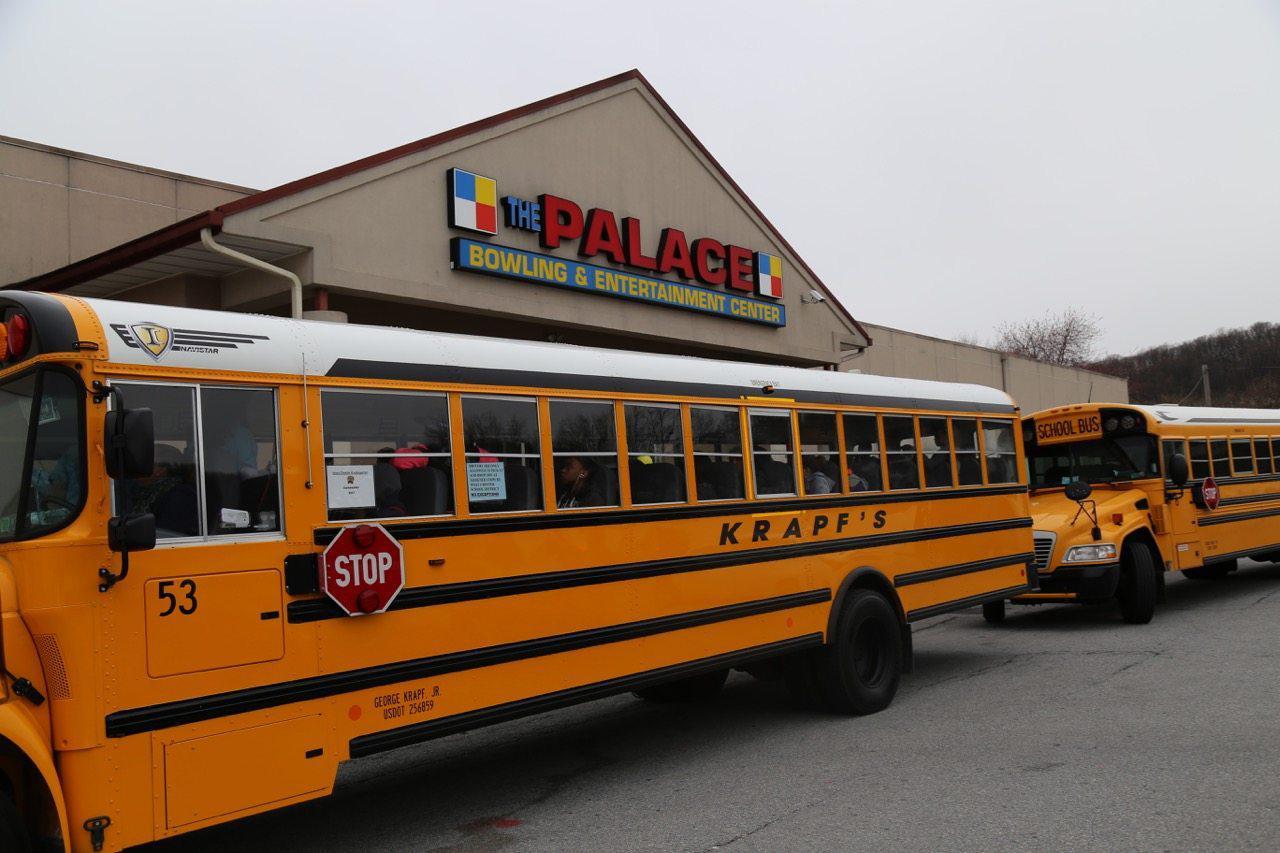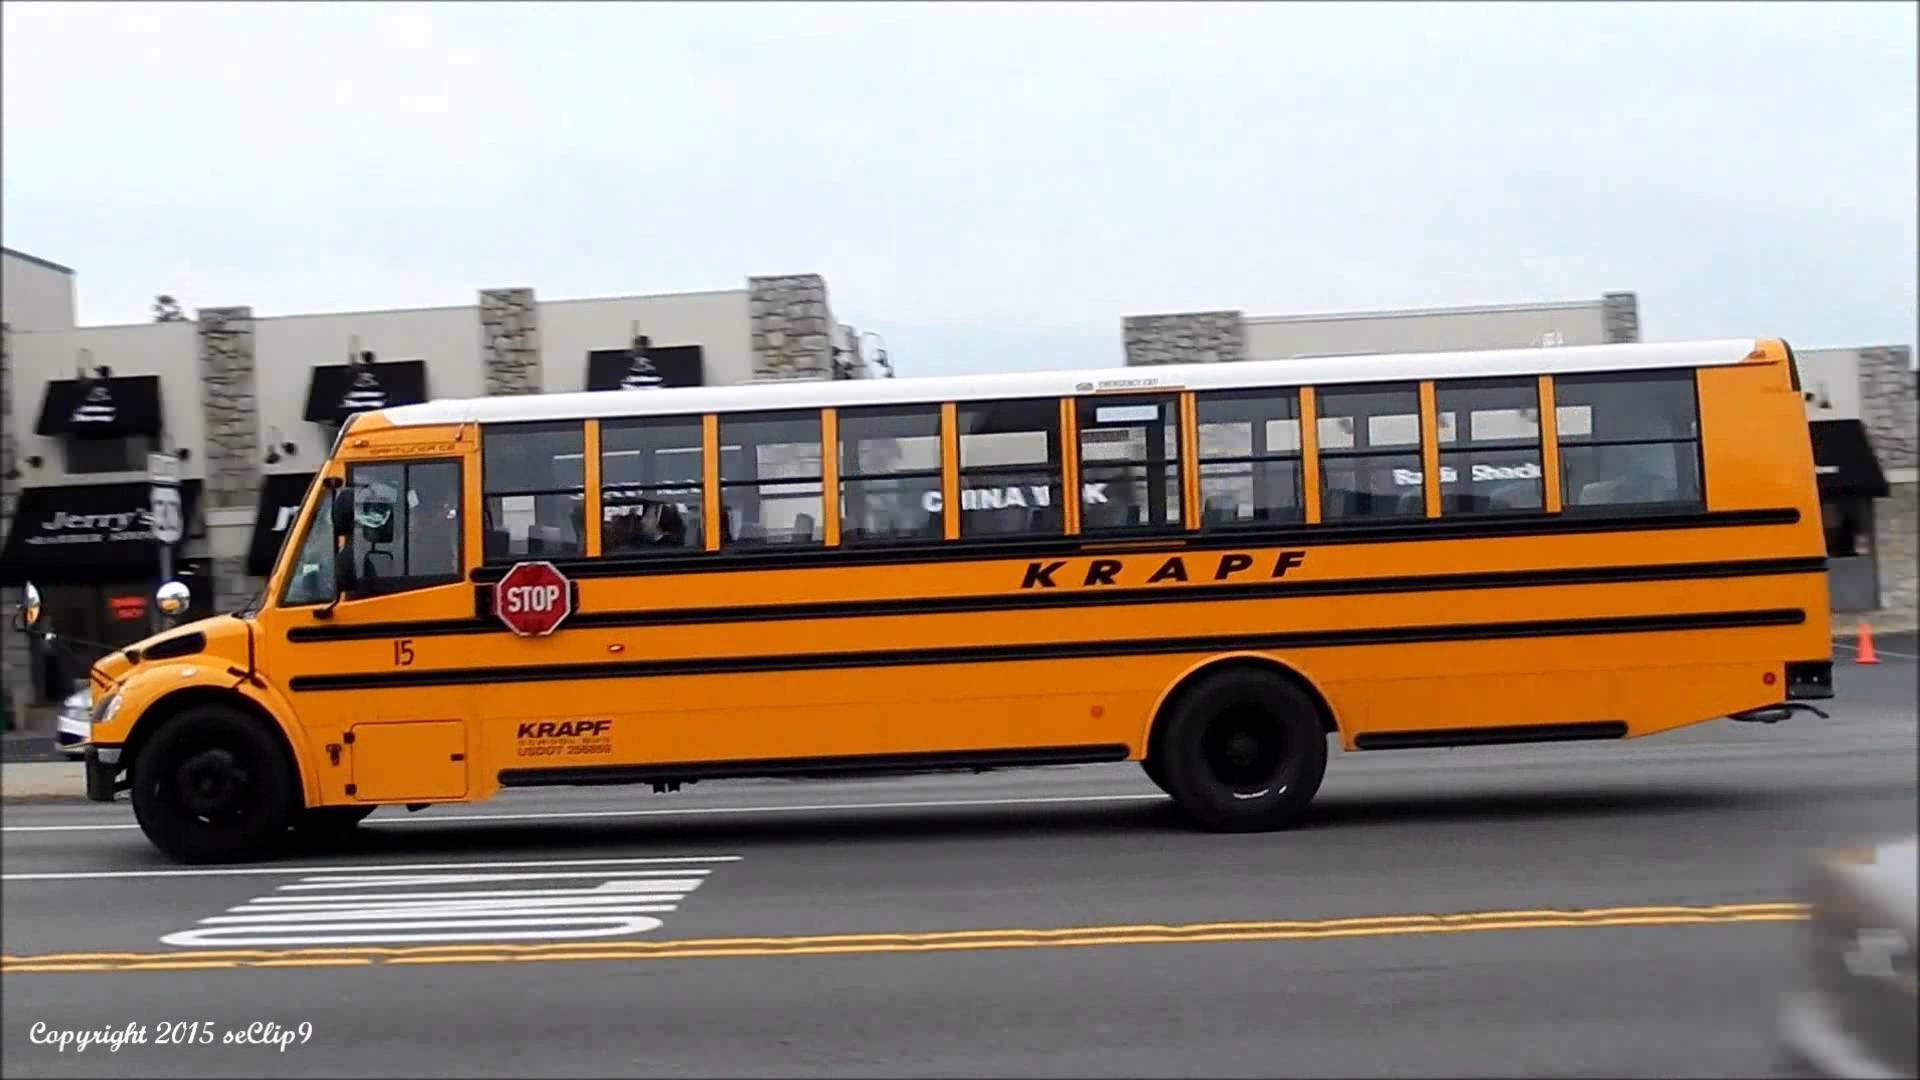The first image is the image on the left, the second image is the image on the right. For the images shown, is this caption "A school bus seen from above has a white roof with identifying number, and a handicap access door directly behind a passenger door with steps." true? Answer yes or no. No. The first image is the image on the left, the second image is the image on the right. Given the left and right images, does the statement "A number is printed on the top of the bus in one of the images." hold true? Answer yes or no. No. 